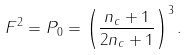<formula> <loc_0><loc_0><loc_500><loc_500>F ^ { 2 } = P _ { 0 } = \left ( \frac { n _ { c } + 1 } { 2 n _ { c } + 1 } \right ) ^ { 3 } .</formula> 